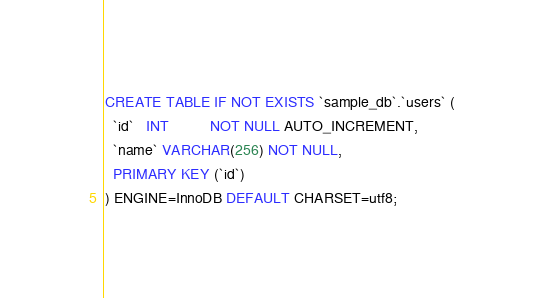<code> <loc_0><loc_0><loc_500><loc_500><_SQL_>CREATE TABLE IF NOT EXISTS `sample_db`.`users` (
  `id`   INT          NOT NULL AUTO_INCREMENT,
  `name` VARCHAR(256) NOT NULL,
  PRIMARY KEY (`id`)
) ENGINE=InnoDB DEFAULT CHARSET=utf8;
</code> 